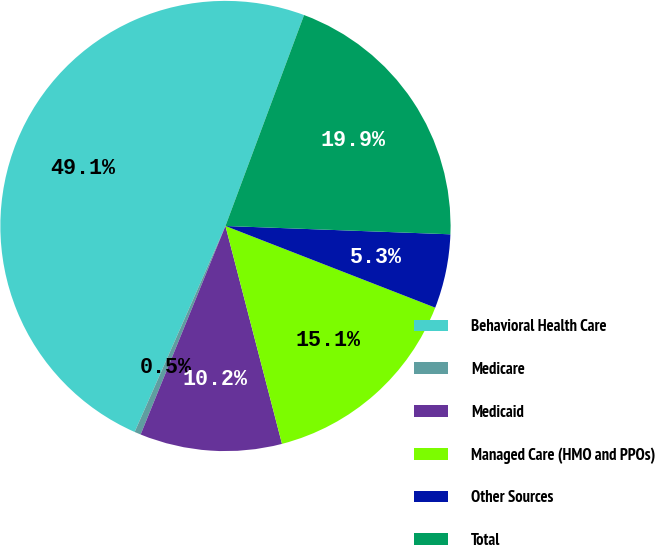Convert chart. <chart><loc_0><loc_0><loc_500><loc_500><pie_chart><fcel>Behavioral Health Care<fcel>Medicare<fcel>Medicaid<fcel>Managed Care (HMO and PPOs)<fcel>Other Sources<fcel>Total<nl><fcel>49.07%<fcel>0.46%<fcel>10.19%<fcel>15.05%<fcel>5.32%<fcel>19.91%<nl></chart> 